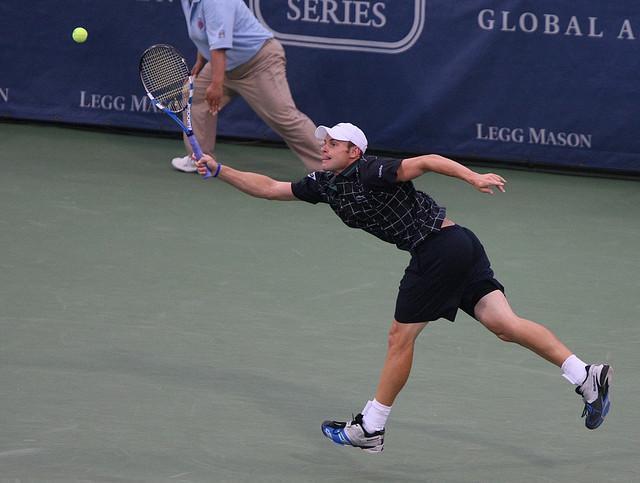How many people can you see?
Give a very brief answer. 2. 